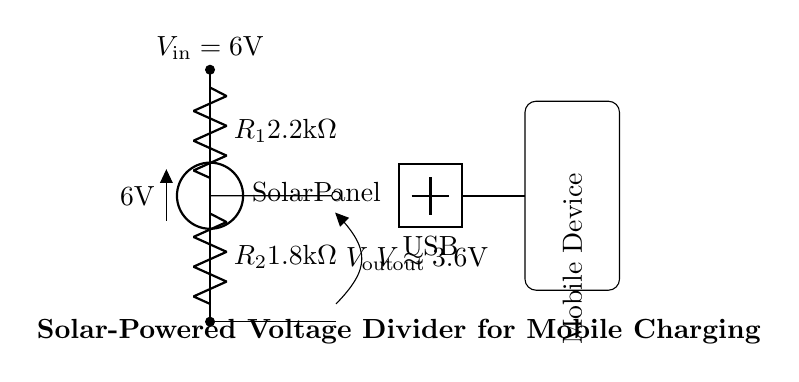What is the input voltage of the circuit? The input voltage is indicated at the solar panel, which is labeled as six volts.
Answer: six volts What are the resistor values in this circuit? The circuit includes two resistors: resistor one is two point two kilo ohms, and resistor two is one point eight kilo ohms.
Answer: two point two kilo ohms and one point eight kilo ohms What is the output voltage of the voltage divider? The output voltage is shown in the diagram as approximately three point six volts, which results from the voltage drop across the resistors.
Answer: three point six volts What does the USB symbol represent in this circuit? The USB symbol indicates the output connection type for charging, showing that the circuit is designed to connect with USB devices.
Answer: USB What are the roles of resistors in this voltage divider? Resistors in a voltage divider reduce the output voltage by controlling the current flow, allowing for the desired voltage (three point six volts) to charge mobile devices.
Answer: reduce the voltage How is the output connected to a mobile device? The output is connected to the mobile device through a wire, visible leading from the USB connection to the rectangle labeled as the mobile device.
Answer: through a wire What is the purpose of this circuit during power failures? The circuit is designed to charge mobile devices using solar power when traditional power sources are unavailable, providing an alternative charging solution.
Answer: charge mobile devices 